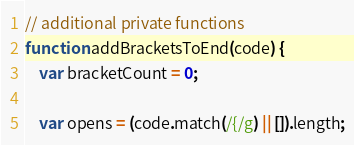<code> <loc_0><loc_0><loc_500><loc_500><_JavaScript_>

// additional private functions
function addBracketsToEnd(code) {
    var bracketCount = 0;

    var opens = (code.match(/{/g) || []).length;</code> 